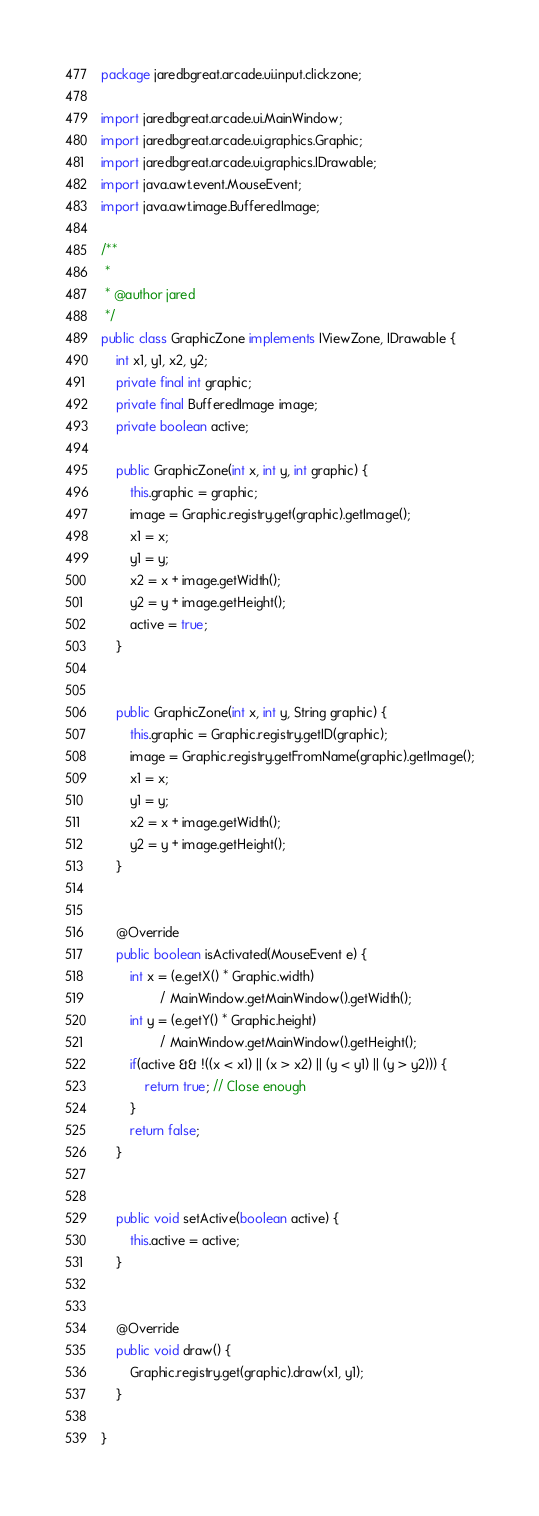<code> <loc_0><loc_0><loc_500><loc_500><_Java_>package jaredbgreat.arcade.ui.input.clickzone;

import jaredbgreat.arcade.ui.MainWindow;
import jaredbgreat.arcade.ui.graphics.Graphic;
import jaredbgreat.arcade.ui.graphics.IDrawable;
import java.awt.event.MouseEvent;
import java.awt.image.BufferedImage;

/**
 *
 * @author jared
 */
public class GraphicZone implements IViewZone, IDrawable {
    int x1, y1, x2, y2;
    private final int graphic;
    private final BufferedImage image;
    private boolean active;

    public GraphicZone(int x, int y, int graphic) {
        this.graphic = graphic;
        image = Graphic.registry.get(graphic).getImage();
        x1 = x;
        y1 = y;
        x2 = x + image.getWidth();
        y2 = y + image.getHeight();
        active = true;
    }
    

    public GraphicZone(int x, int y, String graphic) {
        this.graphic = Graphic.registry.getID(graphic);
        image = Graphic.registry.getFromName(graphic).getImage();
        x1 = x;
        y1 = y;
        x2 = x + image.getWidth();
        y2 = y + image.getHeight();
    }
    

    @Override
    public boolean isActivated(MouseEvent e) {
        int x = (e.getX() * Graphic.width) 
                / MainWindow.getMainWindow().getWidth();
        int y = (e.getY() * Graphic.height) 
                / MainWindow.getMainWindow().getHeight();
        if(active && !((x < x1) || (x > x2) || (y < y1) || (y > y2))) {
            return true; // Close enough
        }
        return false;
    }
    
    
    public void setActive(boolean active) {
        this.active = active;
    }
    

    @Override
    public void draw() {
        Graphic.registry.get(graphic).draw(x1, y1);
    }
    
}
</code> 